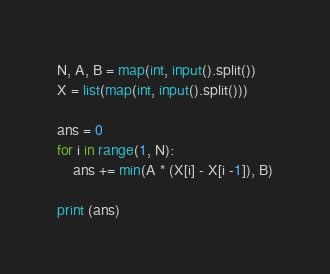Convert code to text. <code><loc_0><loc_0><loc_500><loc_500><_Python_>N, A, B = map(int, input().split())
X = list(map(int, input().split()))

ans = 0
for i in range(1, N):
    ans += min(A * (X[i] - X[i -1]), B)

print (ans)</code> 